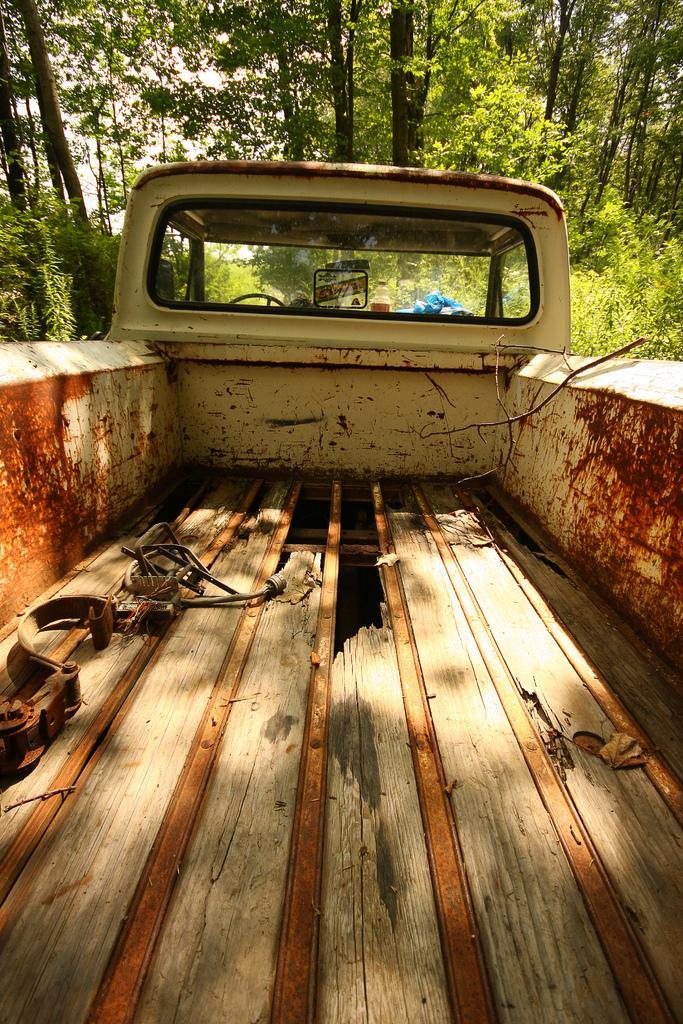Describe this image in one or two sentences. In this image I can see the truck which is in cream and red color. To the side of the truck I can see many trees. In the back there is a white sky. 